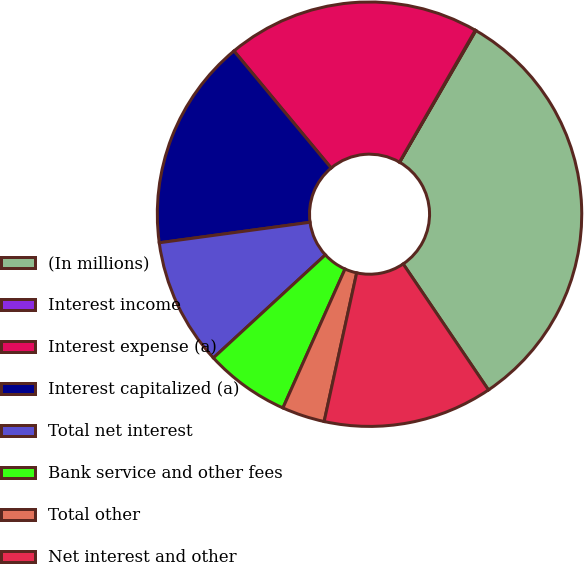Convert chart to OTSL. <chart><loc_0><loc_0><loc_500><loc_500><pie_chart><fcel>(In millions)<fcel>Interest income<fcel>Interest expense (a)<fcel>Interest capitalized (a)<fcel>Total net interest<fcel>Bank service and other fees<fcel>Total other<fcel>Net interest and other<nl><fcel>32.18%<fcel>0.05%<fcel>19.33%<fcel>16.12%<fcel>9.69%<fcel>6.47%<fcel>3.26%<fcel>12.9%<nl></chart> 